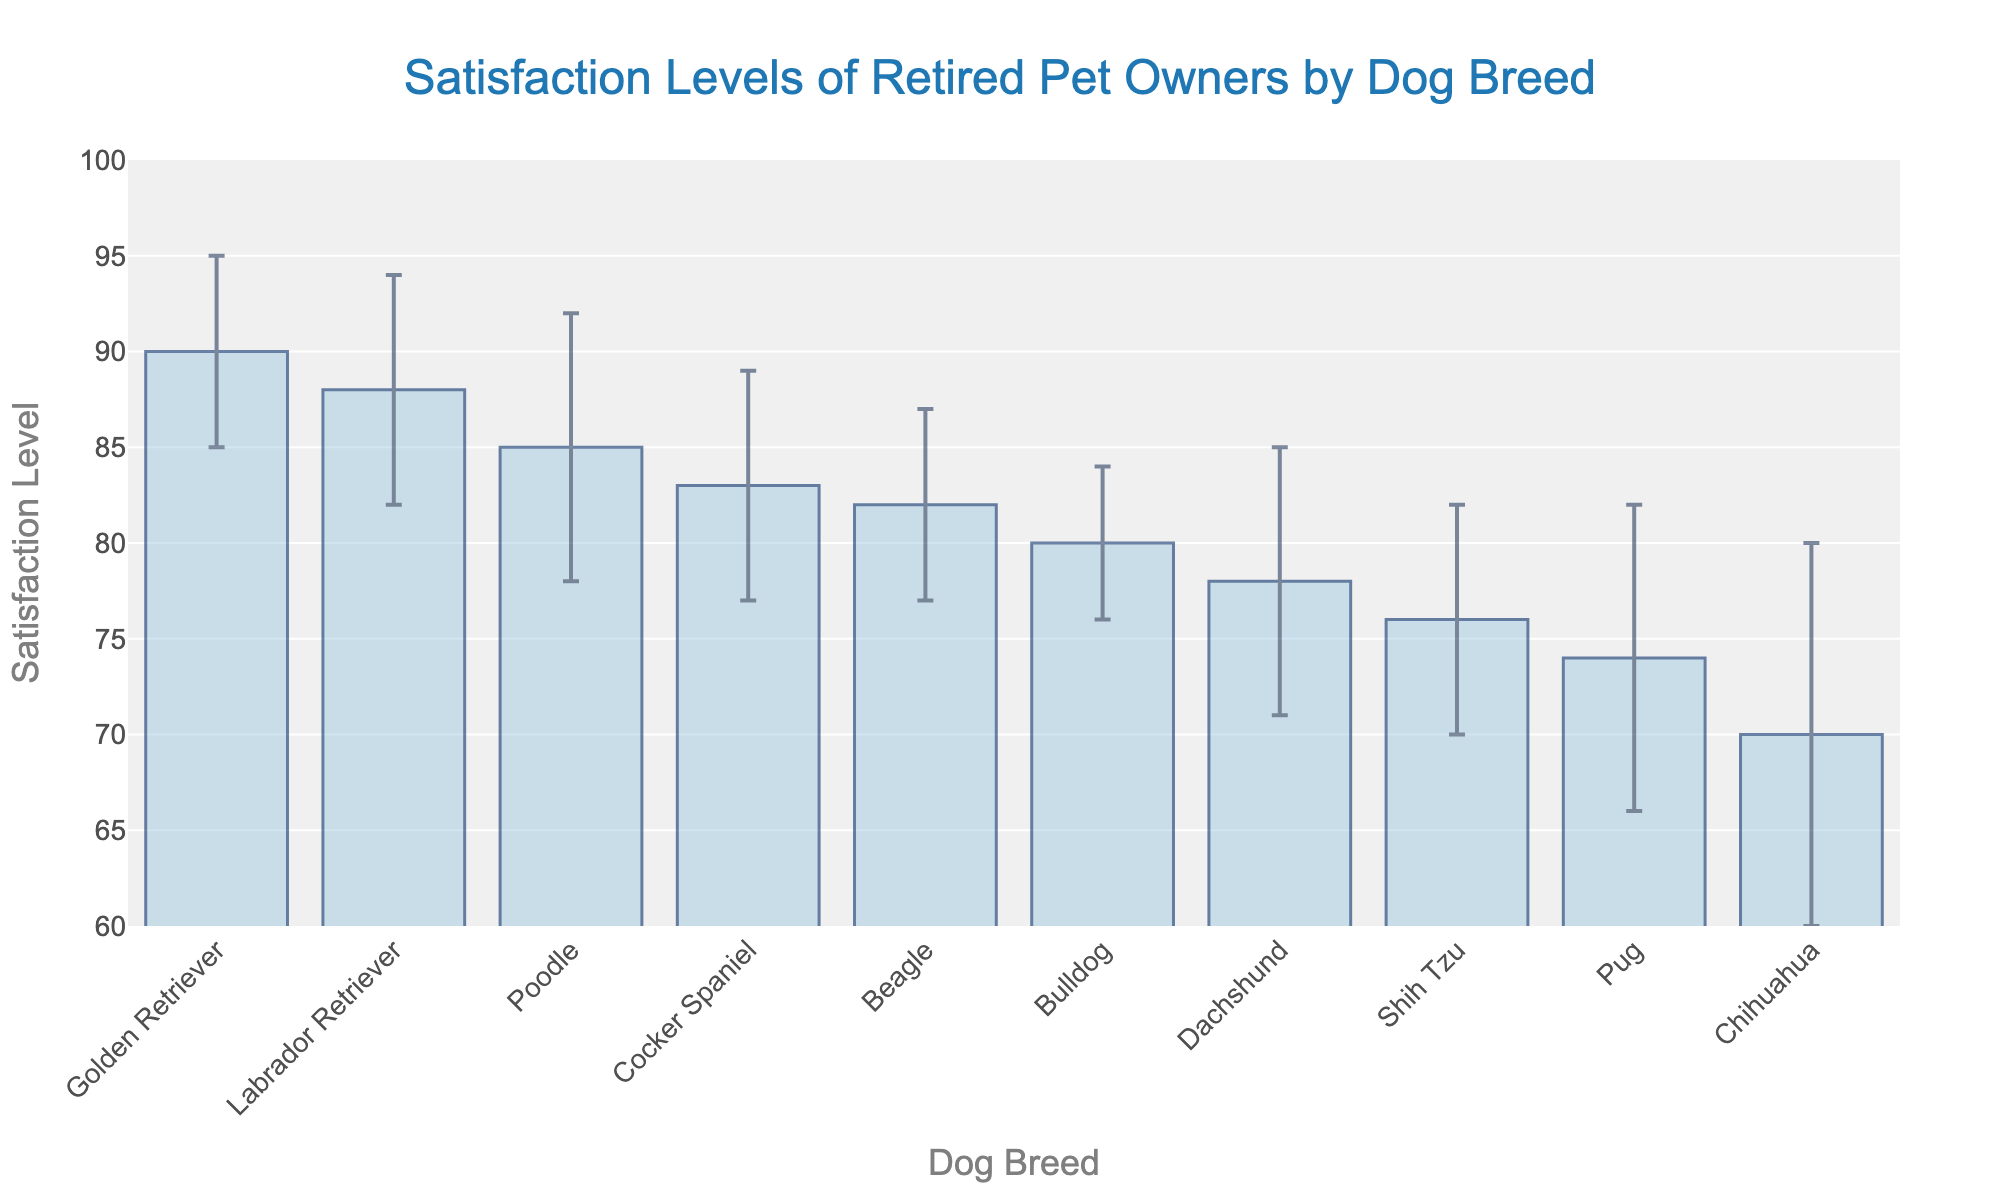What is the title of the figure? The title of the figure is typically placed at the top and is meant to summarize the content of the chart. In this case, it indicates what is being measured and compared.
Answer: Satisfaction Levels of Retired Pet Owners by Dog Breed Which dog breed has the highest satisfaction level? To determine the dog breed with the highest satisfaction level, look for the bar that reaches the highest point on the y-axis.
Answer: Golden Retriever What is the satisfaction level for a Beagle? Look at the bar corresponding to the Beagle on the x-axis and read its height on the y-axis.
Answer: 82 Which dog breed has the largest standard deviation? The largest standard deviation is represented by the longest error bar. Look for the breed with the largest error bar above and below its satisfaction level.
Answer: Chihuahua How many dog breeds have a satisfaction level of at least 80? Identify the bars that reach or exceed the y-axis value of 80. Count these bars.
Answer: 6 Which dog breeds have standard deviations greater than 6? Look at the error bars for each breed. Identify and count those breeds with error bars extending more than 6 units above and below the satisfaction level.
Answer: Poodle, Dachshund, Pug, Chihuahua Is the satisfaction level of a Poodle greater than that of a Bulldog? Compare the heights of the bars for Poodle and Bulldog based on their satisfaction levels.
Answer: Yes Which breed has a higher satisfaction level: Dachshund or Shih Tzu? Compare the heights of the bars for Dachshund and Shih Tzu on the y-axis.
Answer: Dachshund 